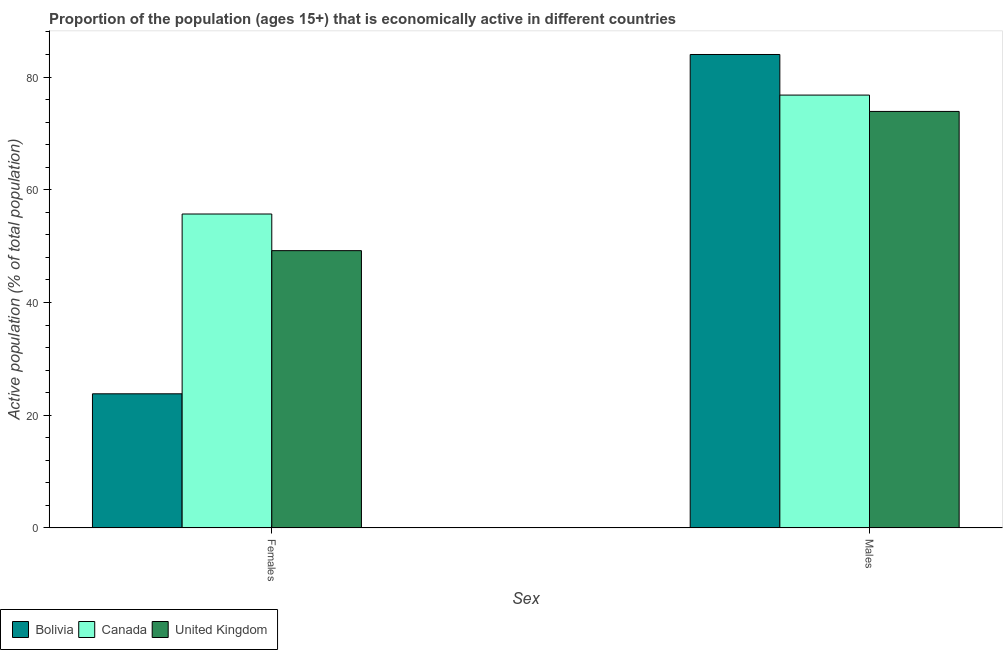Are the number of bars per tick equal to the number of legend labels?
Make the answer very short. Yes. How many bars are there on the 1st tick from the right?
Make the answer very short. 3. What is the label of the 2nd group of bars from the left?
Your answer should be compact. Males. What is the percentage of economically active male population in Canada?
Provide a succinct answer. 76.8. Across all countries, what is the maximum percentage of economically active male population?
Offer a very short reply. 84. Across all countries, what is the minimum percentage of economically active male population?
Your response must be concise. 73.9. What is the total percentage of economically active male population in the graph?
Offer a terse response. 234.7. What is the difference between the percentage of economically active female population in Bolivia and that in Canada?
Offer a terse response. -31.9. What is the difference between the percentage of economically active male population in Canada and the percentage of economically active female population in Bolivia?
Provide a succinct answer. 53. What is the average percentage of economically active male population per country?
Provide a short and direct response. 78.23. What is the difference between the percentage of economically active male population and percentage of economically active female population in Bolivia?
Your response must be concise. 60.2. What is the ratio of the percentage of economically active male population in Canada to that in United Kingdom?
Make the answer very short. 1.04. Is the percentage of economically active male population in Bolivia less than that in Canada?
Keep it short and to the point. No. In how many countries, is the percentage of economically active male population greater than the average percentage of economically active male population taken over all countries?
Offer a very short reply. 1. What does the 1st bar from the left in Females represents?
Give a very brief answer. Bolivia. What does the 3rd bar from the right in Males represents?
Your answer should be compact. Bolivia. How many bars are there?
Provide a succinct answer. 6. How many countries are there in the graph?
Give a very brief answer. 3. Are the values on the major ticks of Y-axis written in scientific E-notation?
Your answer should be compact. No. Does the graph contain any zero values?
Your answer should be compact. No. Does the graph contain grids?
Make the answer very short. No. Where does the legend appear in the graph?
Provide a succinct answer. Bottom left. What is the title of the graph?
Keep it short and to the point. Proportion of the population (ages 15+) that is economically active in different countries. What is the label or title of the X-axis?
Your answer should be very brief. Sex. What is the label or title of the Y-axis?
Provide a short and direct response. Active population (% of total population). What is the Active population (% of total population) in Bolivia in Females?
Your response must be concise. 23.8. What is the Active population (% of total population) in Canada in Females?
Your answer should be very brief. 55.7. What is the Active population (% of total population) in United Kingdom in Females?
Keep it short and to the point. 49.2. What is the Active population (% of total population) in Bolivia in Males?
Offer a terse response. 84. What is the Active population (% of total population) of Canada in Males?
Offer a very short reply. 76.8. What is the Active population (% of total population) of United Kingdom in Males?
Provide a short and direct response. 73.9. Across all Sex, what is the maximum Active population (% of total population) in Canada?
Provide a short and direct response. 76.8. Across all Sex, what is the maximum Active population (% of total population) in United Kingdom?
Your answer should be compact. 73.9. Across all Sex, what is the minimum Active population (% of total population) of Bolivia?
Offer a terse response. 23.8. Across all Sex, what is the minimum Active population (% of total population) of Canada?
Ensure brevity in your answer.  55.7. Across all Sex, what is the minimum Active population (% of total population) of United Kingdom?
Keep it short and to the point. 49.2. What is the total Active population (% of total population) in Bolivia in the graph?
Keep it short and to the point. 107.8. What is the total Active population (% of total population) in Canada in the graph?
Offer a terse response. 132.5. What is the total Active population (% of total population) of United Kingdom in the graph?
Make the answer very short. 123.1. What is the difference between the Active population (% of total population) of Bolivia in Females and that in Males?
Ensure brevity in your answer.  -60.2. What is the difference between the Active population (% of total population) of Canada in Females and that in Males?
Your answer should be compact. -21.1. What is the difference between the Active population (% of total population) in United Kingdom in Females and that in Males?
Offer a terse response. -24.7. What is the difference between the Active population (% of total population) of Bolivia in Females and the Active population (% of total population) of Canada in Males?
Offer a very short reply. -53. What is the difference between the Active population (% of total population) of Bolivia in Females and the Active population (% of total population) of United Kingdom in Males?
Provide a short and direct response. -50.1. What is the difference between the Active population (% of total population) of Canada in Females and the Active population (% of total population) of United Kingdom in Males?
Offer a very short reply. -18.2. What is the average Active population (% of total population) in Bolivia per Sex?
Provide a short and direct response. 53.9. What is the average Active population (% of total population) in Canada per Sex?
Make the answer very short. 66.25. What is the average Active population (% of total population) of United Kingdom per Sex?
Keep it short and to the point. 61.55. What is the difference between the Active population (% of total population) of Bolivia and Active population (% of total population) of Canada in Females?
Offer a very short reply. -31.9. What is the difference between the Active population (% of total population) in Bolivia and Active population (% of total population) in United Kingdom in Females?
Give a very brief answer. -25.4. What is the difference between the Active population (% of total population) in Canada and Active population (% of total population) in United Kingdom in Females?
Give a very brief answer. 6.5. What is the ratio of the Active population (% of total population) in Bolivia in Females to that in Males?
Give a very brief answer. 0.28. What is the ratio of the Active population (% of total population) of Canada in Females to that in Males?
Give a very brief answer. 0.73. What is the ratio of the Active population (% of total population) in United Kingdom in Females to that in Males?
Provide a succinct answer. 0.67. What is the difference between the highest and the second highest Active population (% of total population) of Bolivia?
Give a very brief answer. 60.2. What is the difference between the highest and the second highest Active population (% of total population) of Canada?
Your answer should be very brief. 21.1. What is the difference between the highest and the second highest Active population (% of total population) in United Kingdom?
Give a very brief answer. 24.7. What is the difference between the highest and the lowest Active population (% of total population) of Bolivia?
Offer a terse response. 60.2. What is the difference between the highest and the lowest Active population (% of total population) in Canada?
Your answer should be compact. 21.1. What is the difference between the highest and the lowest Active population (% of total population) of United Kingdom?
Your response must be concise. 24.7. 